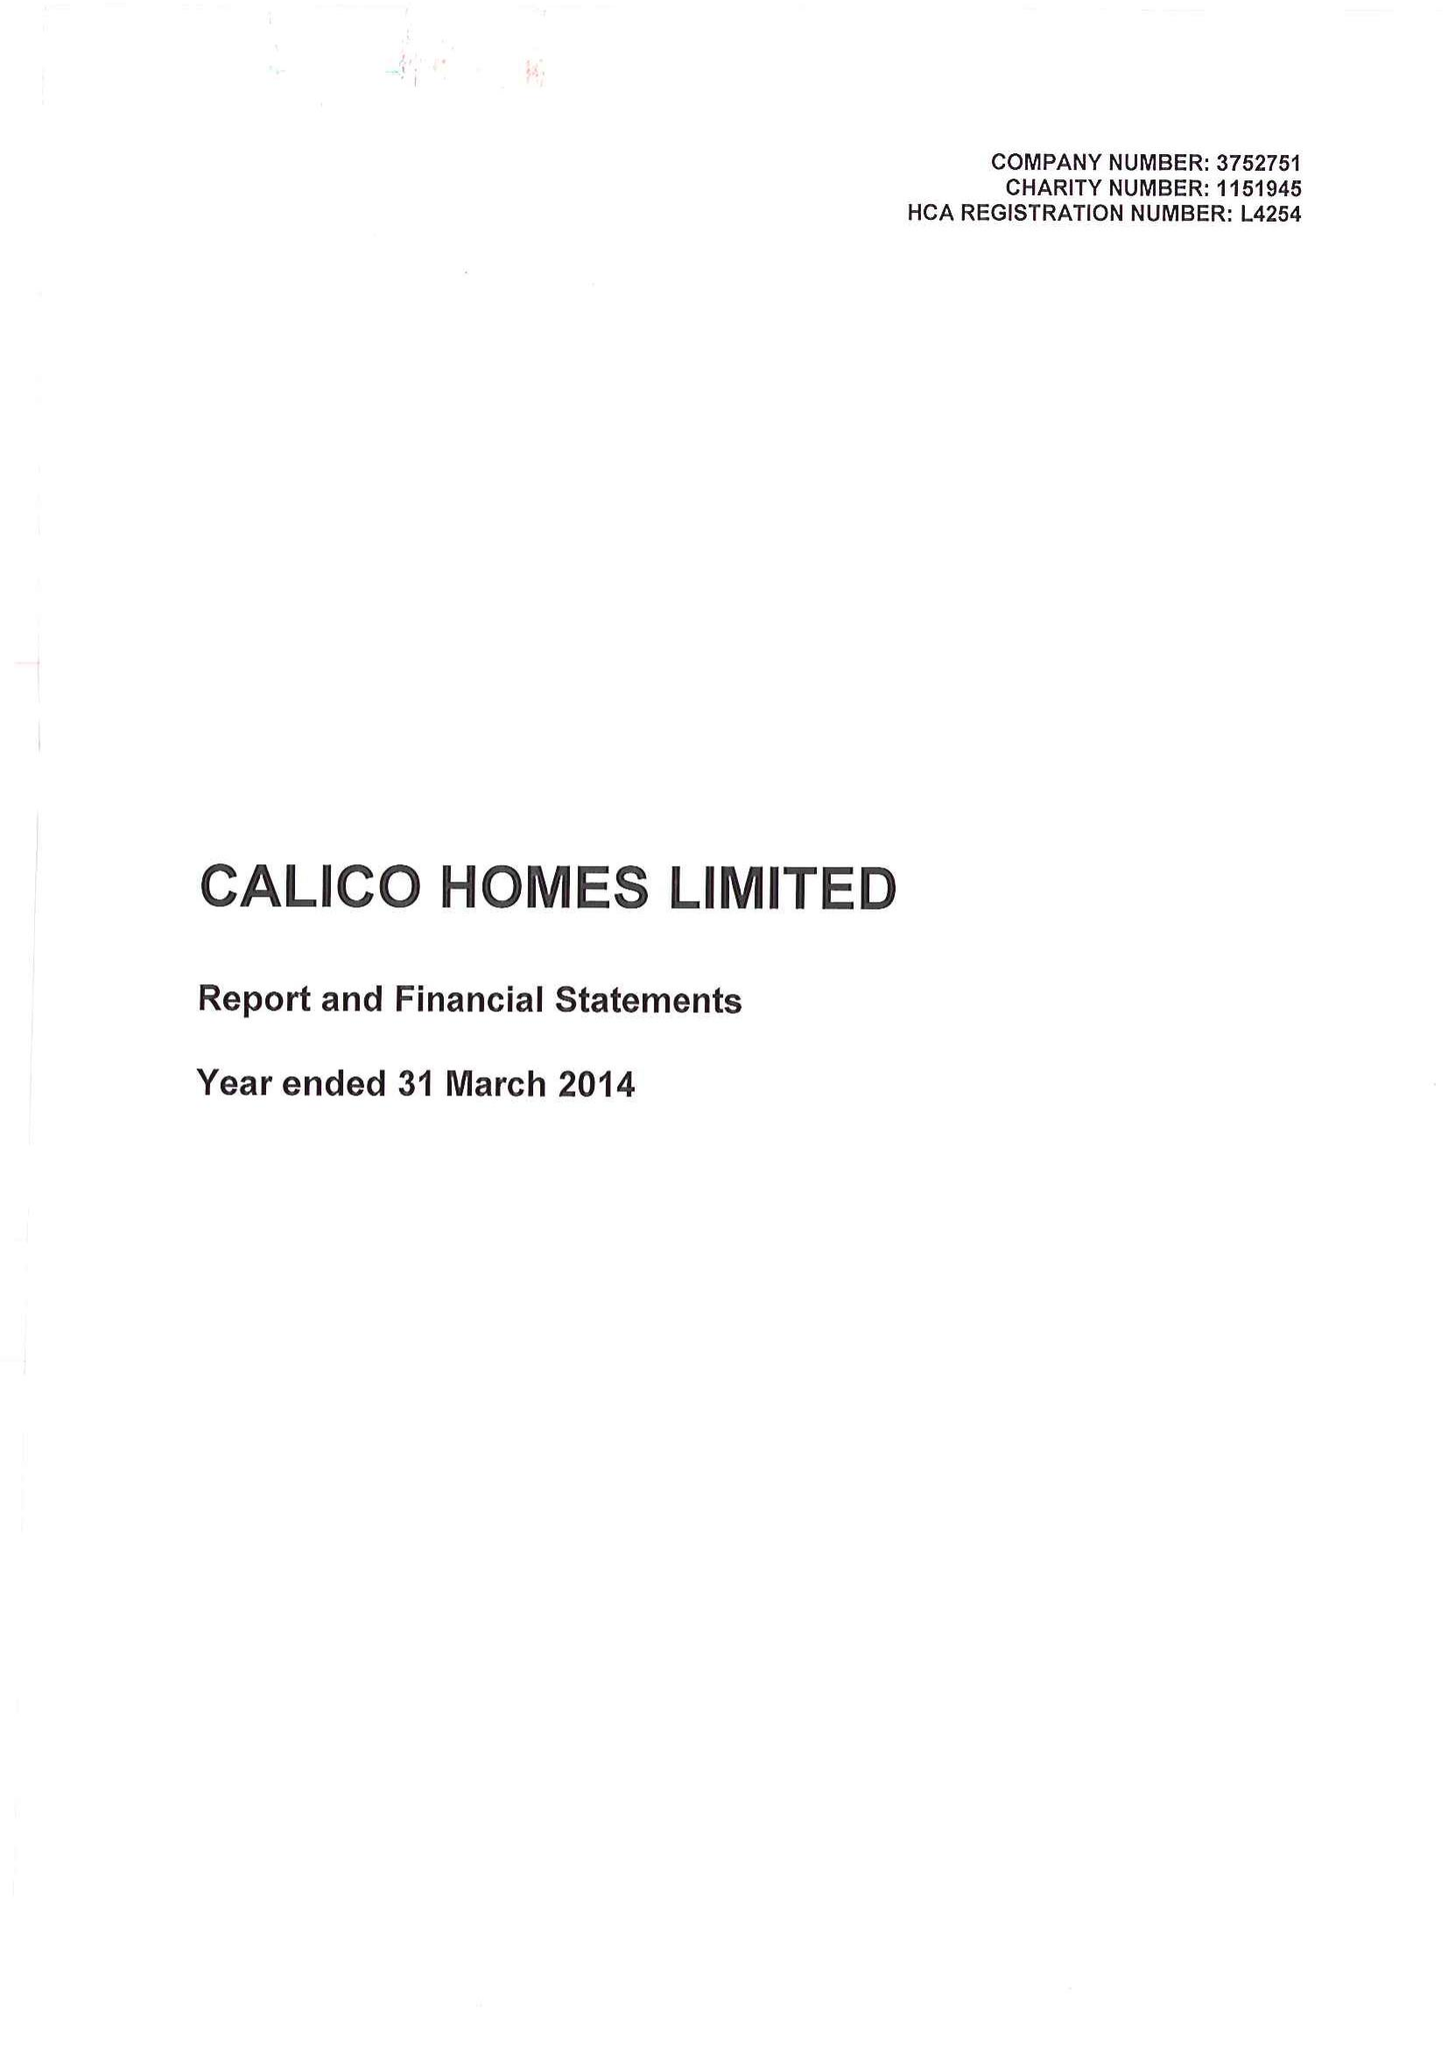What is the value for the charity_name?
Answer the question using a single word or phrase. Calico Homes Ltd. 